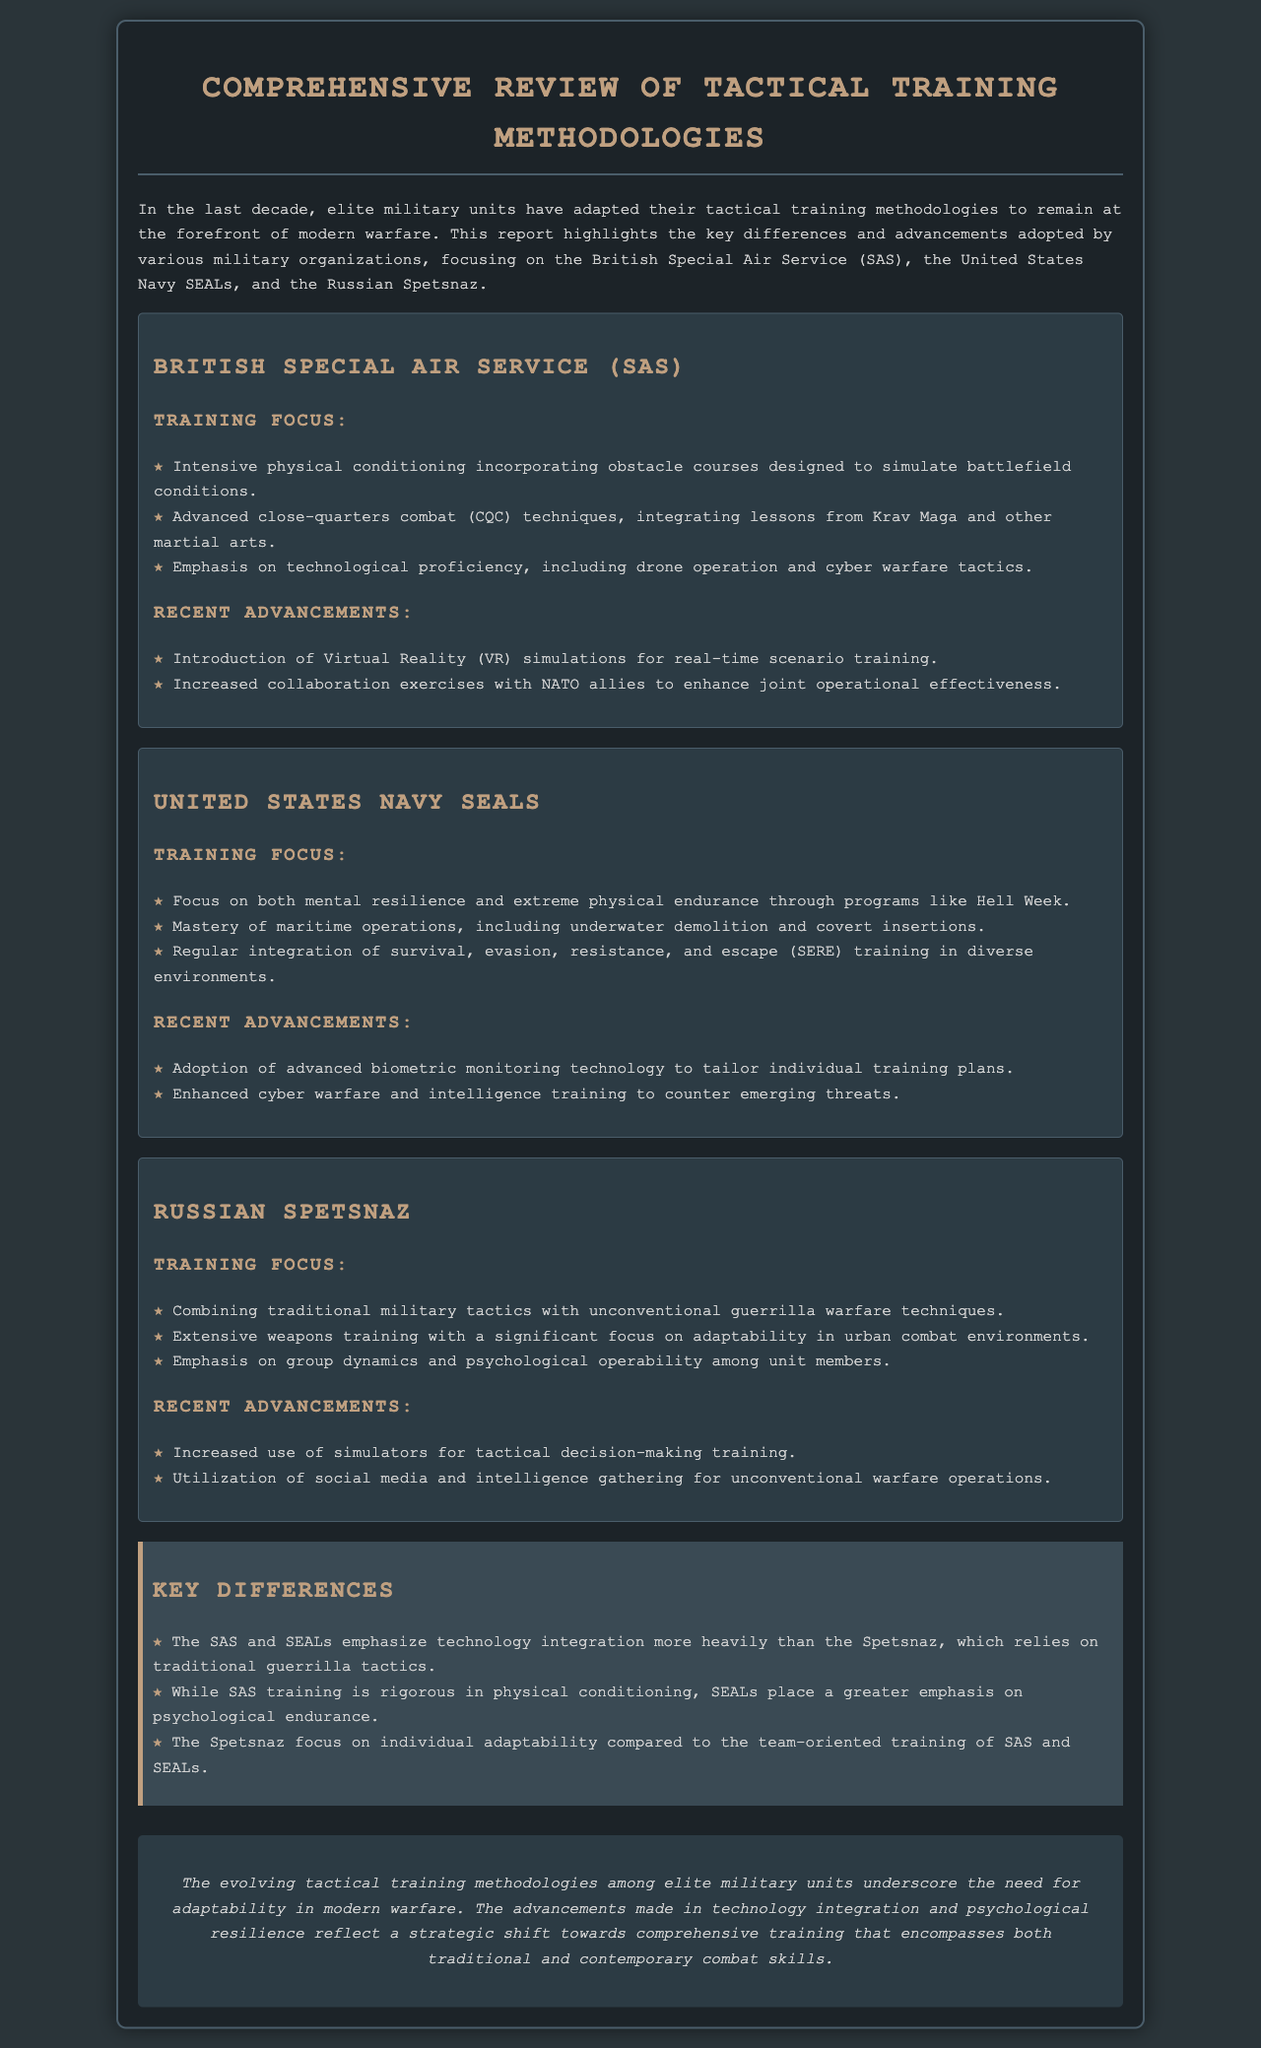what is the primary focus of SAS training? The primary focus of SAS training includes intensive physical conditioning, advanced close-quarters combat techniques, and technological proficiency.
Answer: Intensive physical conditioning what technology has the SAS recently adopted for training? The report mentions the introduction of a specific technology for training purposes, which is highlighted under recent advancements of SAS training.
Answer: Virtual Reality simulations how does SEAL training differ from SAS training? The document outlines the emphasis placed on psychological endurance in SEAL training as compared to SAS training's focus on physical conditioning.
Answer: Psychological endurance what type of warfare techniques does Spetsnaz combine with traditional military tactics? The report specifies the unconventional tactics integrated into Spetsnaz’s training alongside standard military tactics.
Answer: Guerrilla warfare techniques which elite unit focuses on psychological operability among members? The emphasis on group dynamics and psychological aspects within the unit members is a significant aspect referenced for one of the military units.
Answer: Russian Spetsnaz what advancement involves tailoring training plans in SEALs? The advancements made in SEALs training include specific monitoring technology that personalizes training regimens based on individual assessments.
Answer: Biometric monitoring technology how do SAS and SEALs differ from Spetsnaz in technological training? The differences discussed in the document highlight the SAS and SEALs placing more emphasis on technology while Spetsnaz relies more on traditional tactics.
Answer: Technology integration what is a recent advancement in Spetsnaz training? The report lists recent advancements in Spetsnaz training focusing on using specific methods for decision-making exercises.
Answer: Simulators what is the overall theme of the document? The summary encapsulates the main theme that reflects on the adaptation of tactical training methodologies in elite military units in response to contemporary warfare challenges.
Answer: Adaptability in modern warfare 